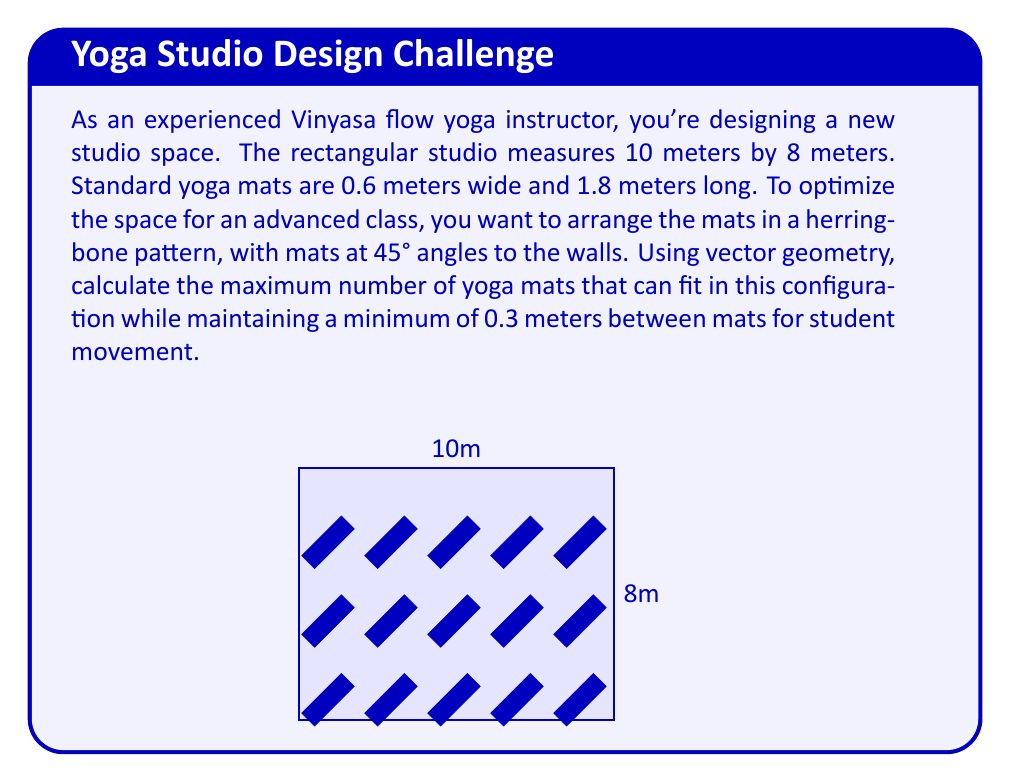Could you help me with this problem? Let's approach this step-by-step:

1) First, we need to determine the space occupied by each mat in the herringbone pattern. The diagonal of a mat forms a 45° angle with the wall.

2) The diagonal length of a mat is:
   $$d = \sqrt{0.6^2 + 1.8^2} = \sqrt{0.36 + 3.24} = \sqrt{3.6} \approx 1.897\text{ m}$$

3) The projection of this diagonal on either wall is:
   $$p = d \cdot \cos(45°) = 1.897 \cdot \frac{\sqrt{2}}{2} \approx 1.341\text{ m}$$

4) Adding the 0.3m spacing, each mat effectively occupies:
   $$1.341 + 0.3 = 1.641\text{ m}$$
   along each wall.

5) For the 10m wall, we can fit:
   $$\lfloor \frac{10}{1.641} \rfloor = 6\text{ mats}$$

6) For the 8m wall, we can fit:
   $$\lfloor \frac{8}{1.641} \rfloor = 4\text{ mats}$$

7) The total number of mats is the product of these two numbers:
   $$6 \cdot 4 = 24\text{ mats}$$

Therefore, the maximum number of yoga mats that can fit in this configuration is 24.
Answer: 24 mats 